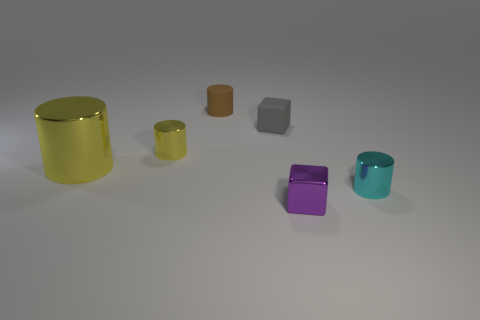Can you describe the lighting and shadows in the scene? The lighting in the scene is soft and diffuse, coming from the upper left, casting gentle shadows to the lower right of the objects, suggesting a calm, indoor environment.  What does the shadowing tell us about the shape of the objects? The shadows confirm the three-dimensional nature of the objects, with the cylindrical items casting elongated curved shadows, while the cubes cast squared shadows, aiding in the perception of their shapes and volumes. 